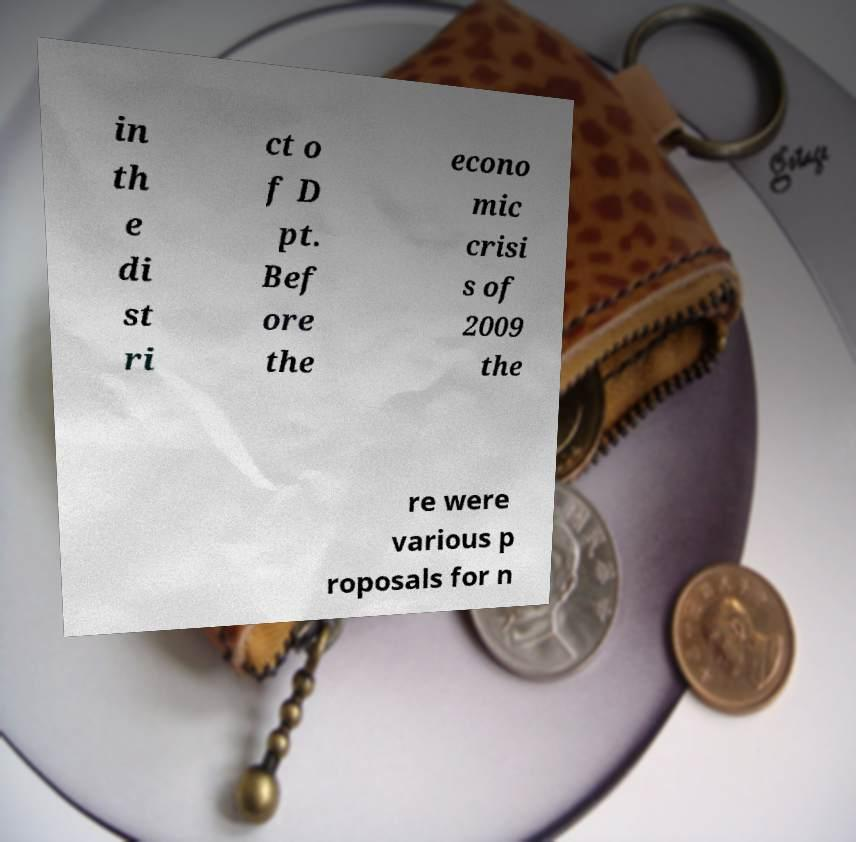Please identify and transcribe the text found in this image. in th e di st ri ct o f D pt. Bef ore the econo mic crisi s of 2009 the re were various p roposals for n 